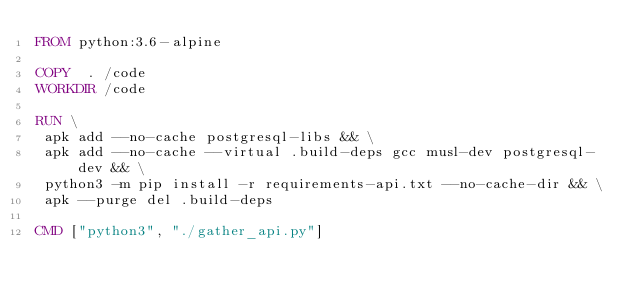<code> <loc_0><loc_0><loc_500><loc_500><_Dockerfile_>FROM python:3.6-alpine

COPY  . /code
WORKDIR /code

RUN \
 apk add --no-cache postgresql-libs && \
 apk add --no-cache --virtual .build-deps gcc musl-dev postgresql-dev && \
 python3 -m pip install -r requirements-api.txt --no-cache-dir && \
 apk --purge del .build-deps

CMD ["python3", "./gather_api.py"]</code> 